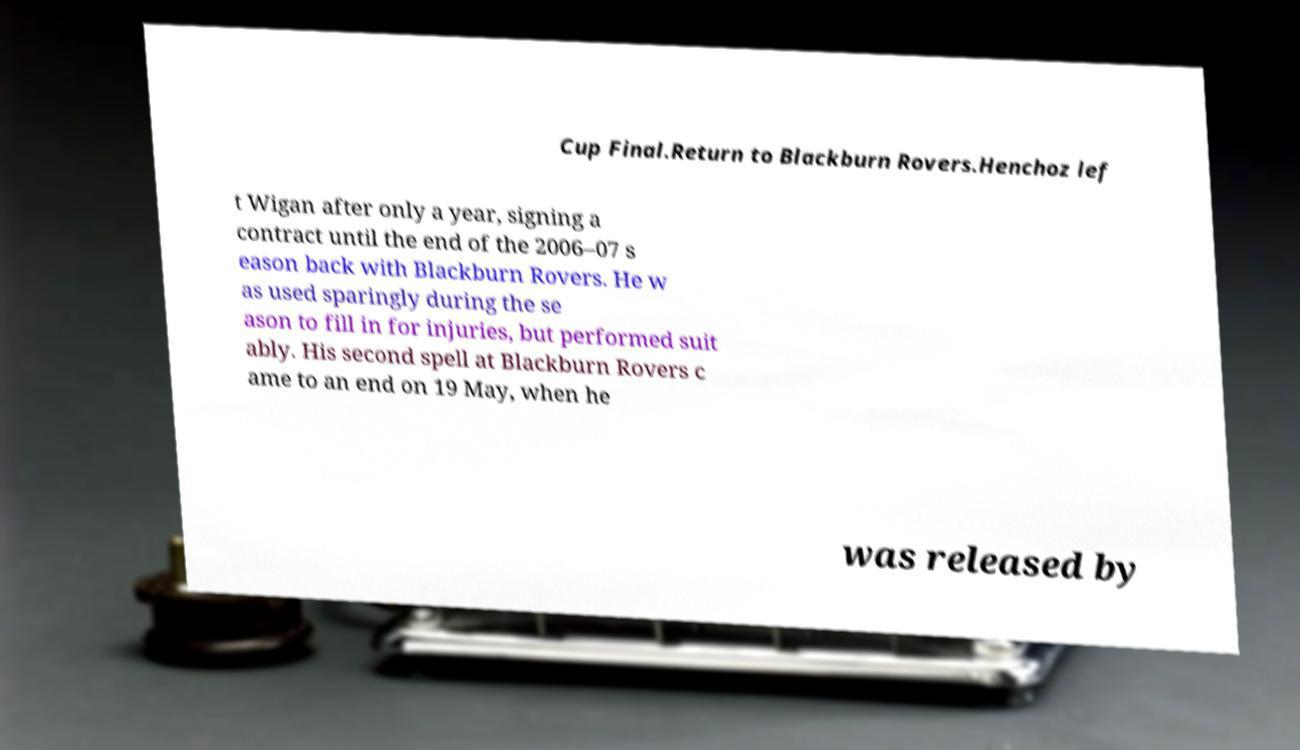For documentation purposes, I need the text within this image transcribed. Could you provide that? Cup Final.Return to Blackburn Rovers.Henchoz lef t Wigan after only a year, signing a contract until the end of the 2006–07 s eason back with Blackburn Rovers. He w as used sparingly during the se ason to fill in for injuries, but performed suit ably. His second spell at Blackburn Rovers c ame to an end on 19 May, when he was released by 